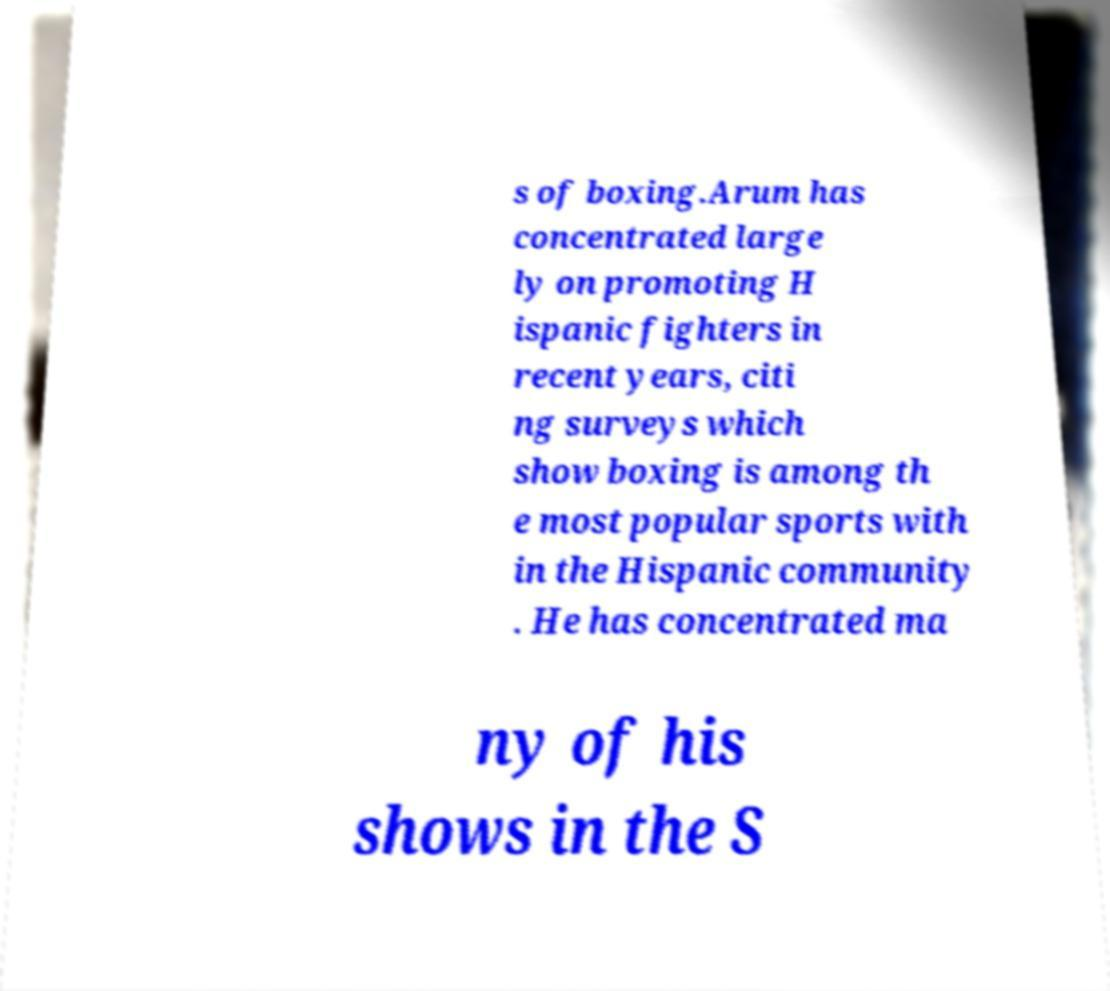Could you assist in decoding the text presented in this image and type it out clearly? s of boxing.Arum has concentrated large ly on promoting H ispanic fighters in recent years, citi ng surveys which show boxing is among th e most popular sports with in the Hispanic community . He has concentrated ma ny of his shows in the S 